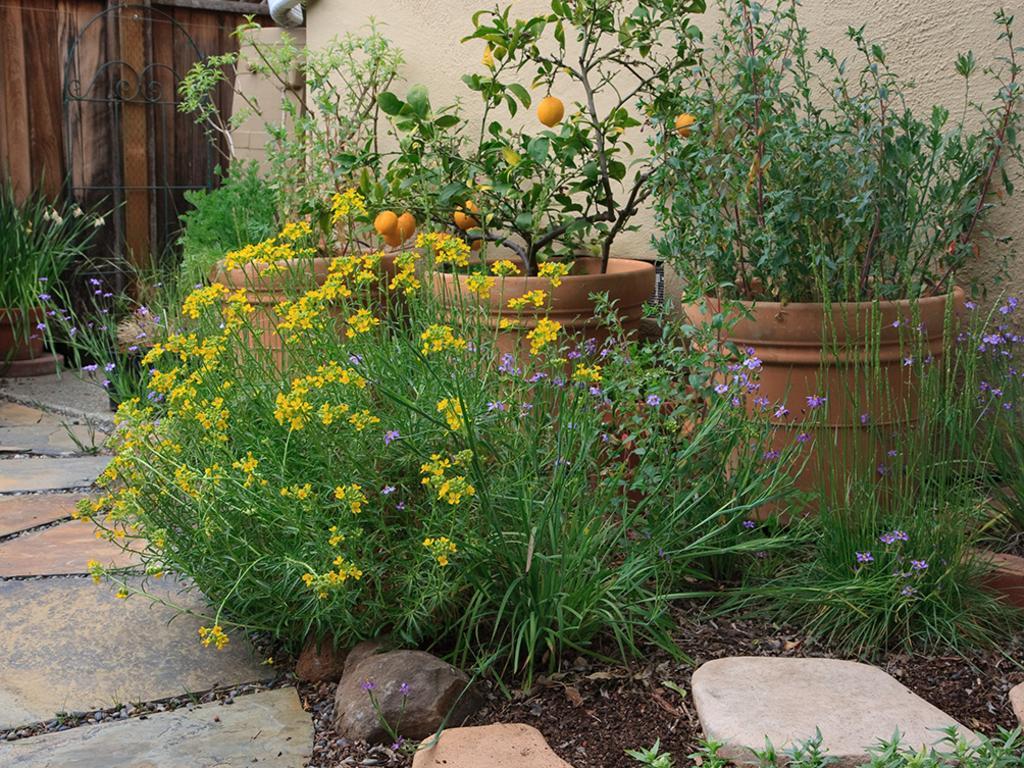Please provide a concise description of this image. Here in this picture we can see plants present all over there and we can see stones present here and there and on that plants we can see flowers and fruits present over there. 